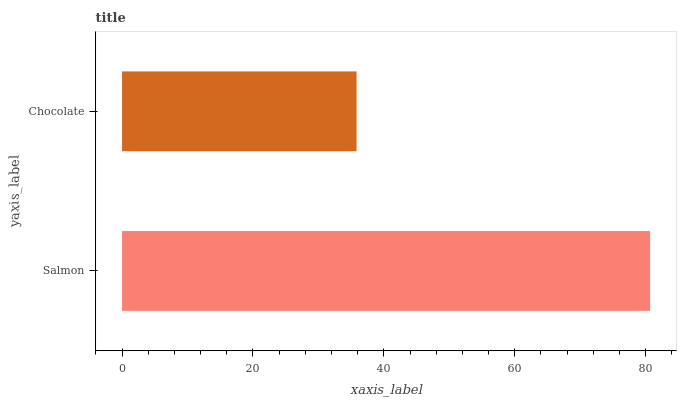Is Chocolate the minimum?
Answer yes or no. Yes. Is Salmon the maximum?
Answer yes or no. Yes. Is Chocolate the maximum?
Answer yes or no. No. Is Salmon greater than Chocolate?
Answer yes or no. Yes. Is Chocolate less than Salmon?
Answer yes or no. Yes. Is Chocolate greater than Salmon?
Answer yes or no. No. Is Salmon less than Chocolate?
Answer yes or no. No. Is Salmon the high median?
Answer yes or no. Yes. Is Chocolate the low median?
Answer yes or no. Yes. Is Chocolate the high median?
Answer yes or no. No. Is Salmon the low median?
Answer yes or no. No. 